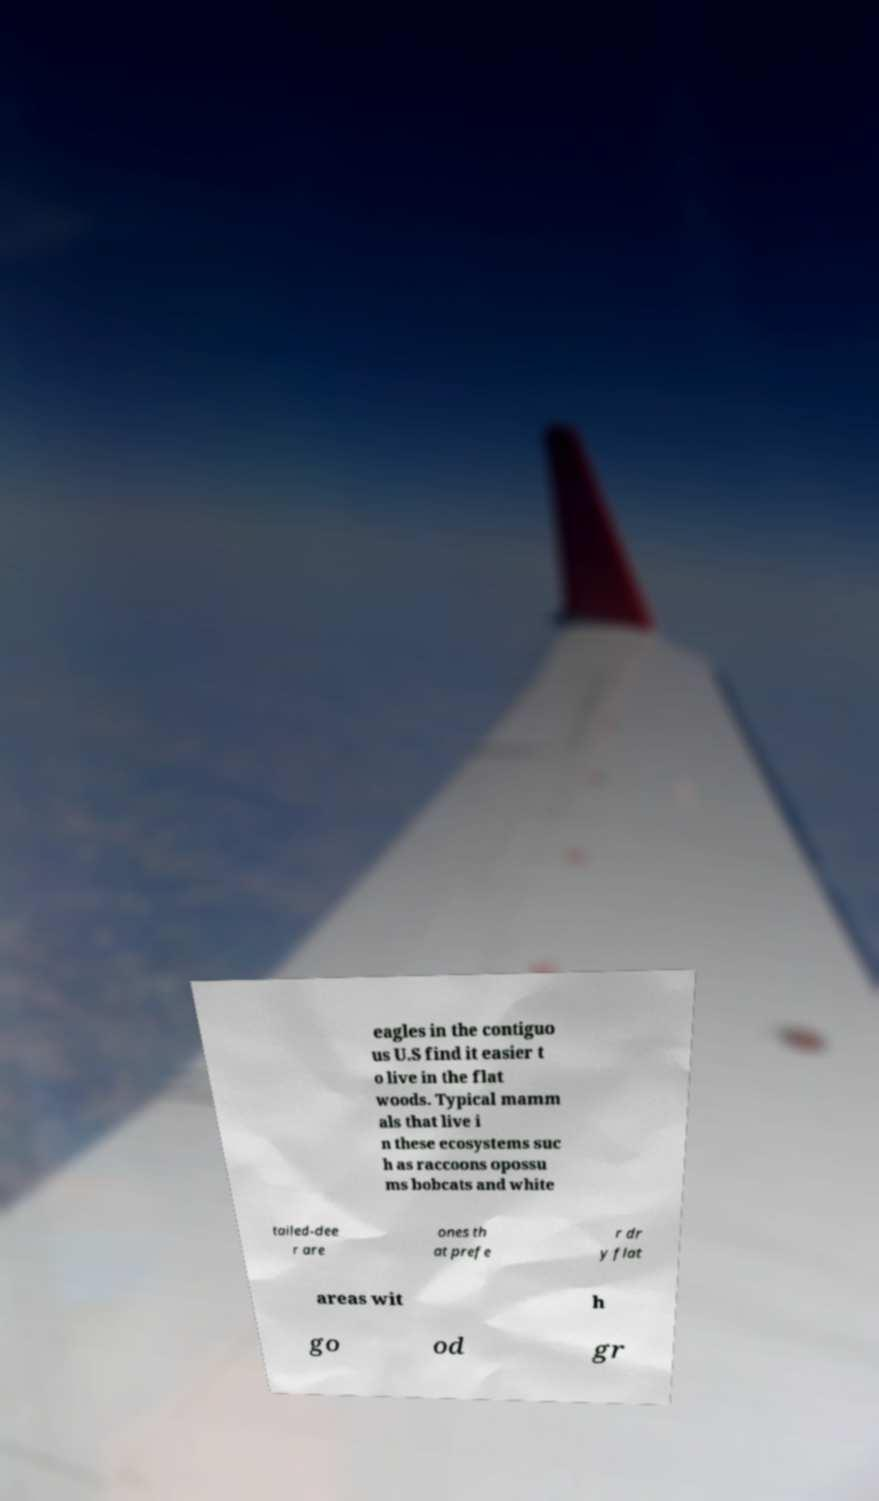For documentation purposes, I need the text within this image transcribed. Could you provide that? eagles in the contiguo us U.S find it easier t o live in the flat woods. Typical mamm als that live i n these ecosystems suc h as raccoons opossu ms bobcats and white tailed-dee r are ones th at prefe r dr y flat areas wit h go od gr 